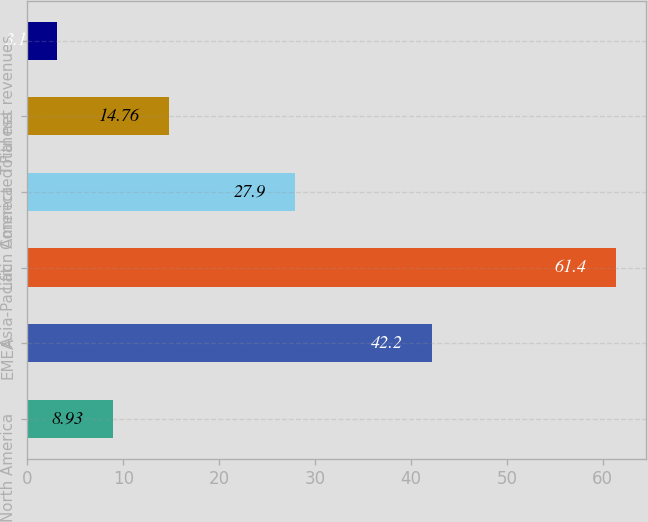Convert chart. <chart><loc_0><loc_0><loc_500><loc_500><bar_chart><fcel>North America<fcel>EMEA<fcel>Asia-Pacific<fcel>Latin America<fcel>Connected Fitness<fcel>Total net revenues<nl><fcel>8.93<fcel>42.2<fcel>61.4<fcel>27.9<fcel>14.76<fcel>3.1<nl></chart> 